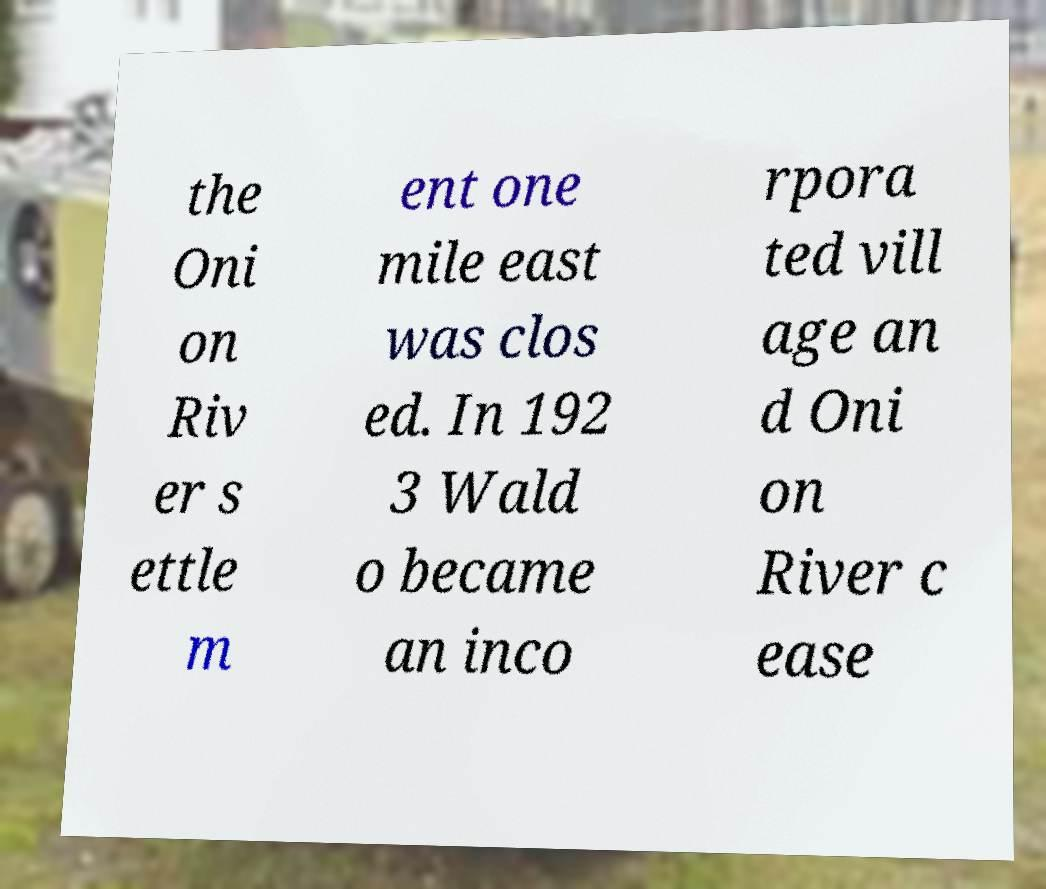Can you accurately transcribe the text from the provided image for me? the Oni on Riv er s ettle m ent one mile east was clos ed. In 192 3 Wald o became an inco rpora ted vill age an d Oni on River c ease 